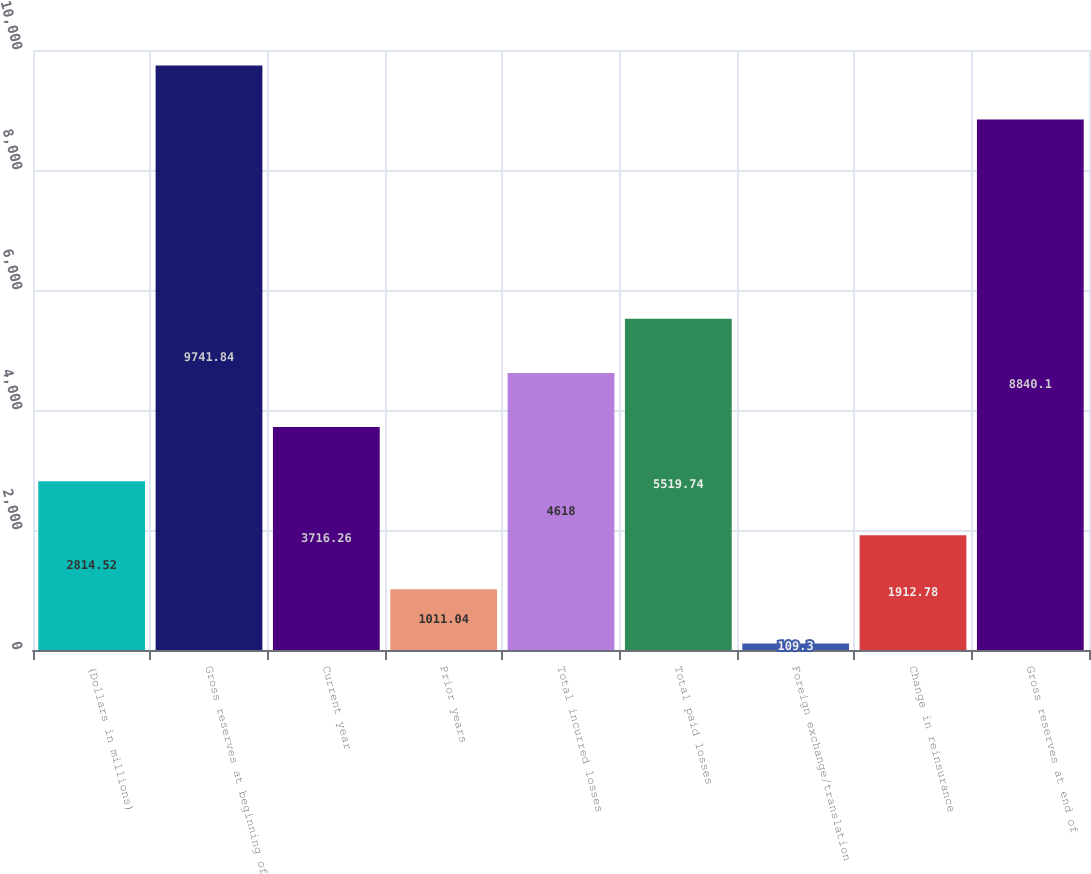<chart> <loc_0><loc_0><loc_500><loc_500><bar_chart><fcel>(Dollars in millions)<fcel>Gross reserves at beginning of<fcel>Current year<fcel>Prior years<fcel>Total incurred losses<fcel>Total paid losses<fcel>Foreign exchange/translation<fcel>Change in reinsurance<fcel>Gross reserves at end of<nl><fcel>2814.52<fcel>9741.84<fcel>3716.26<fcel>1011.04<fcel>4618<fcel>5519.74<fcel>109.3<fcel>1912.78<fcel>8840.1<nl></chart> 